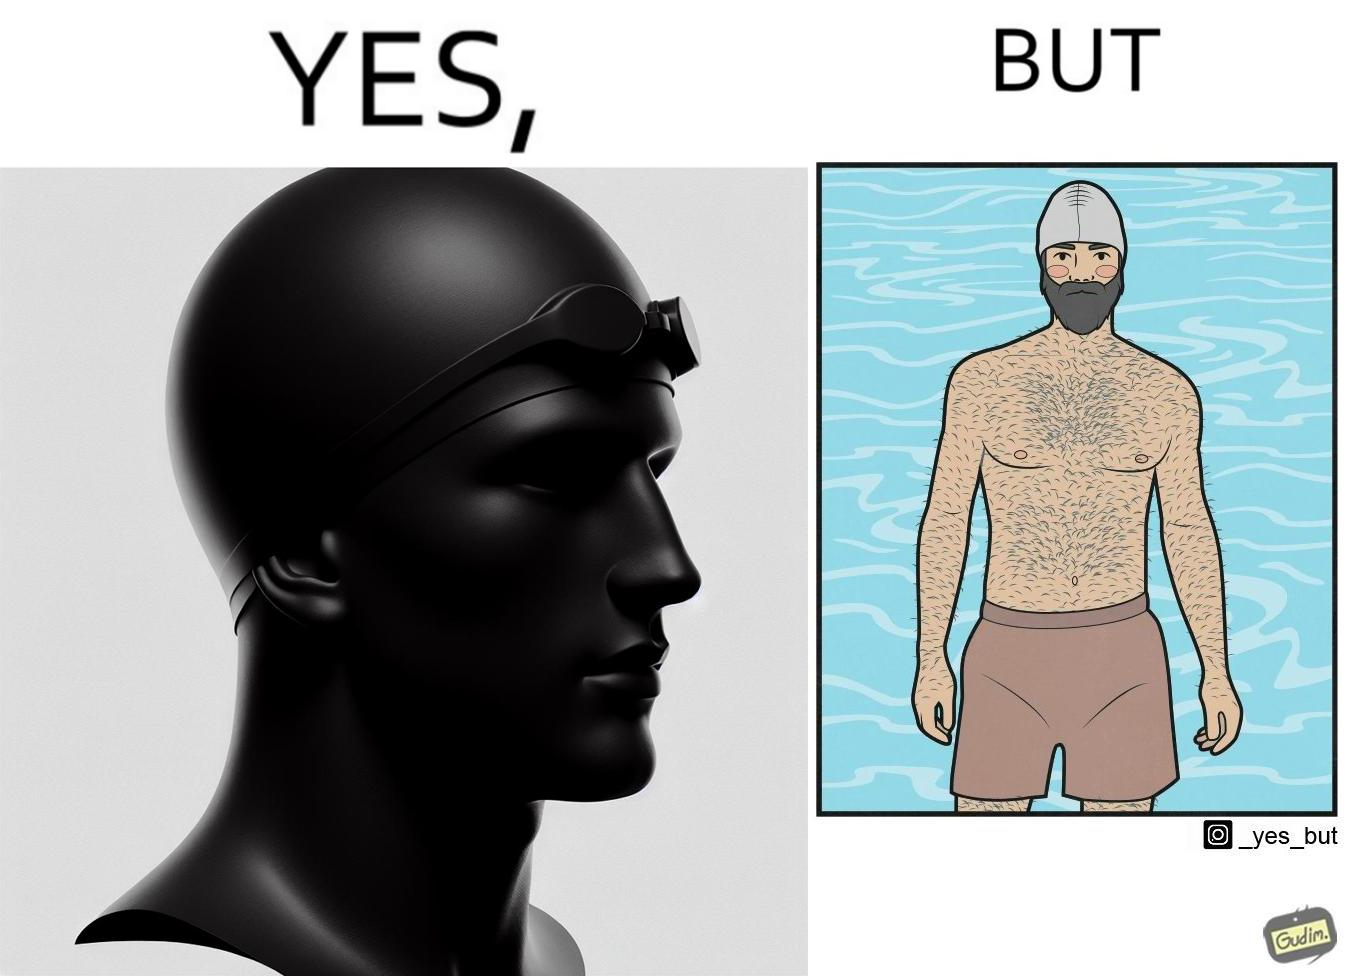Is this a satirical image? Yes, this image is satirical. 